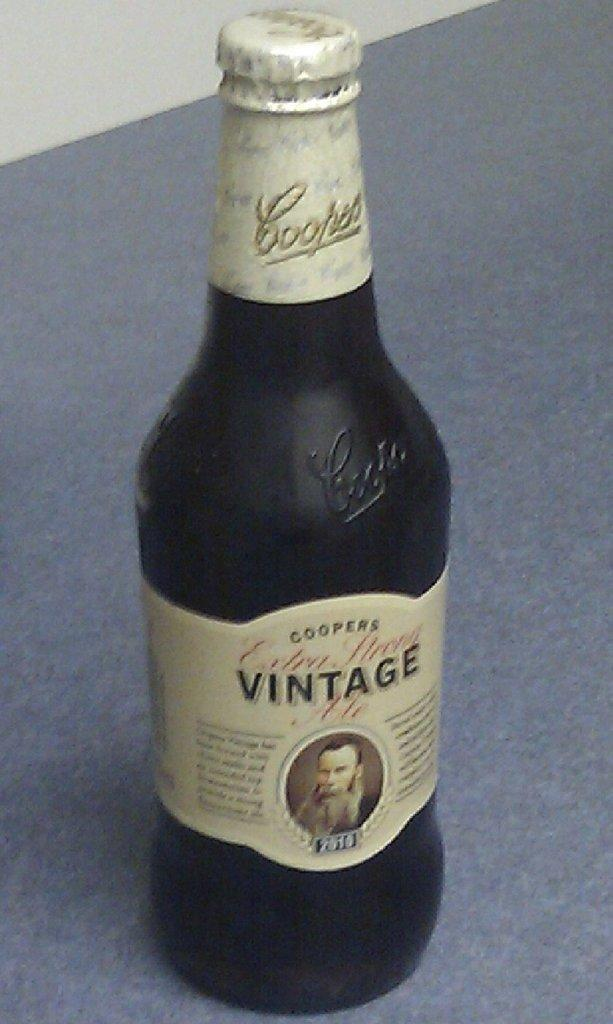<image>
Relay a brief, clear account of the picture shown. the word vintage that is on a bottle 